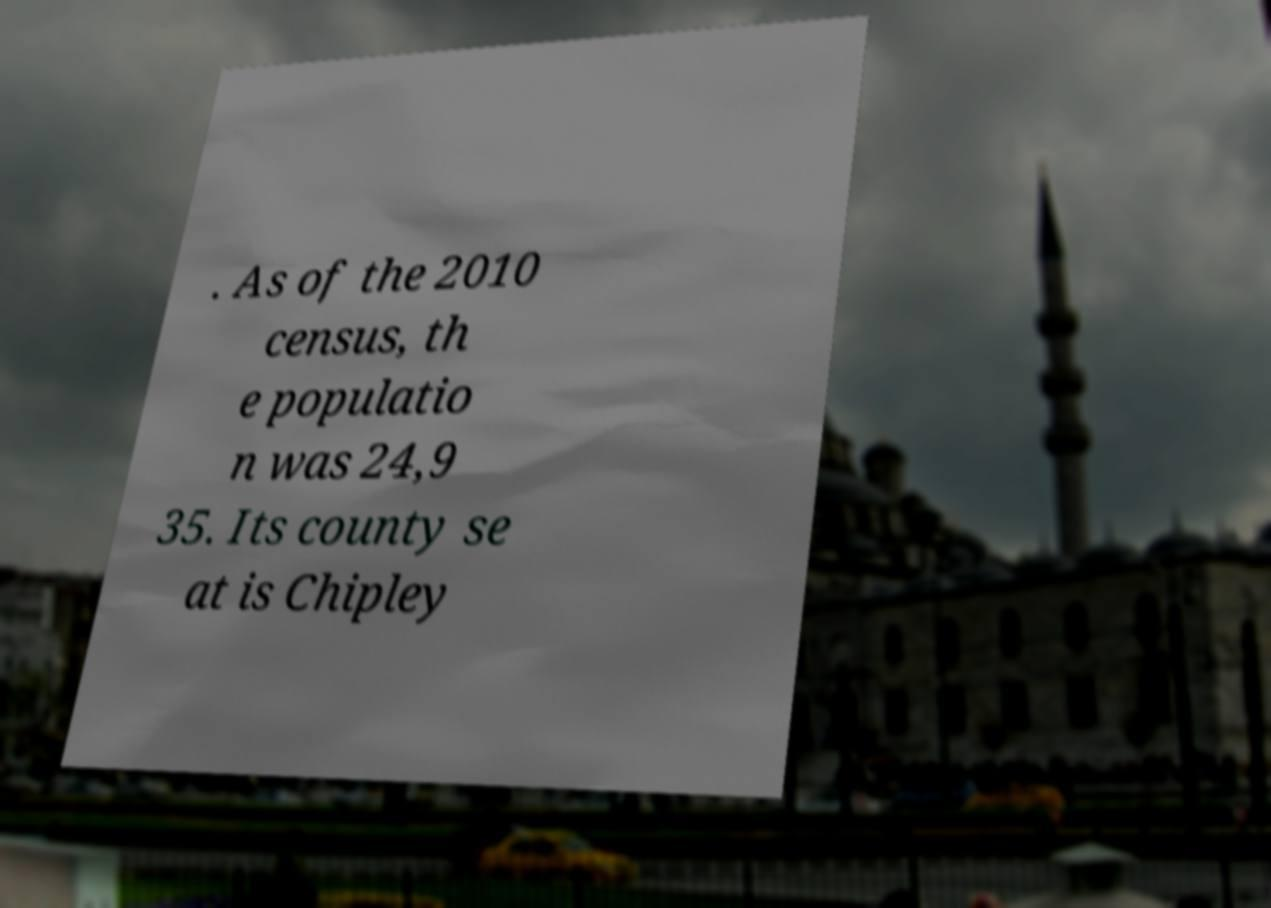Could you extract and type out the text from this image? . As of the 2010 census, th e populatio n was 24,9 35. Its county se at is Chipley 